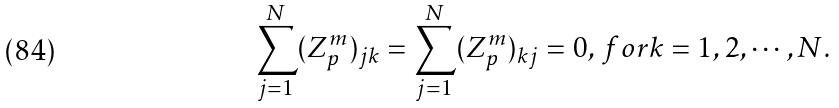<formula> <loc_0><loc_0><loc_500><loc_500>\sum _ { j = 1 } ^ { N } ( Z _ { p } ^ { m } ) _ { j k } = \sum _ { j = 1 } ^ { N } ( Z _ { p } ^ { m } ) _ { k j } = 0 , \, f o r k = 1 , 2 , \cdots , N .</formula> 